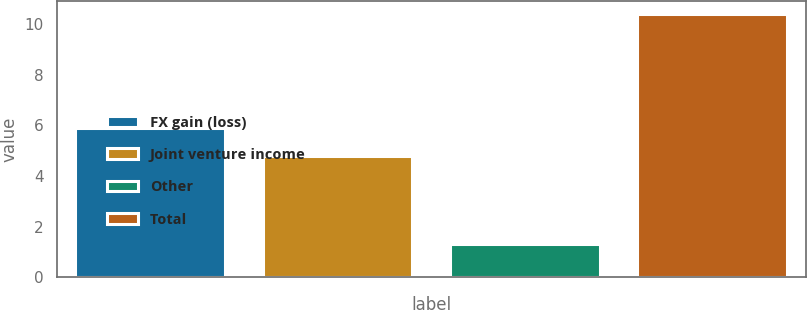Convert chart. <chart><loc_0><loc_0><loc_500><loc_500><bar_chart><fcel>FX gain (loss)<fcel>Joint venture income<fcel>Other<fcel>Total<nl><fcel>5.9<fcel>4.8<fcel>1.3<fcel>10.4<nl></chart> 